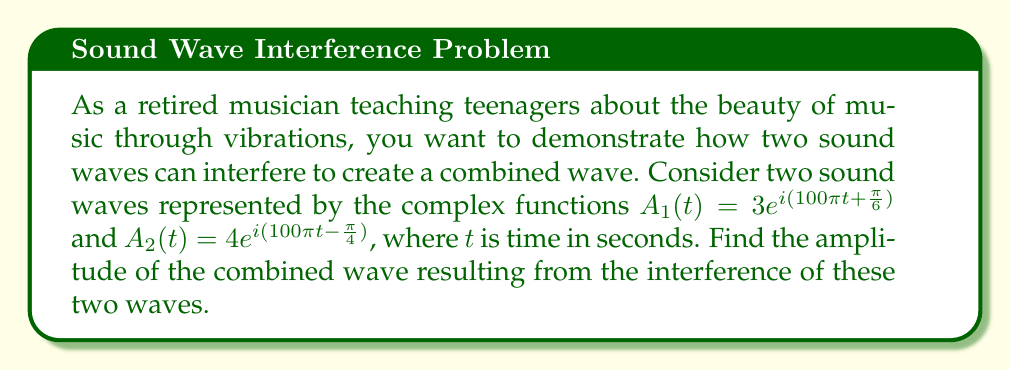What is the answer to this math problem? To find the amplitude of the combined wave, we need to follow these steps:

1) The combined wave is the sum of the two individual waves:
   $$A_{total}(t) = A_1(t) + A_2(t) = 3e^{i(100\pi t + \frac{\pi}{6})} + 4e^{i(100\pi t - \frac{\pi}{4})}$$

2) We can factor out the common $e^{i100\pi t}$ term:
   $$A_{total}(t) = e^{i100\pi t}(3e^{i\frac{\pi}{6}} + 4e^{-i\frac{\pi}{4}})$$

3) Let's focus on the term in parentheses. We need to add these complex numbers:
   $$3e^{i\frac{\pi}{6}} + 4e^{-i\frac{\pi}{4}}$$

4) Convert each complex number to rectangular form:
   $3e^{i\frac{\pi}{6}} = 3(\cos\frac{\pi}{6} + i\sin\frac{\pi}{6}) = 3(\frac{\sqrt{3}}{2} + i\frac{1}{2}) = \frac{3\sqrt{3}}{2} + i\frac{3}{2}$
   $4e^{-i\frac{\pi}{4}} = 4(\cos\frac{\pi}{4} - i\sin\frac{\pi}{4}) = 4(\frac{\sqrt{2}}{2} - i\frac{\sqrt{2}}{2}) = 2\sqrt{2} - i2\sqrt{2}$

5) Add these complex numbers:
   $$(\frac{3\sqrt{3}}{2} + i\frac{3}{2}) + (2\sqrt{2} - i2\sqrt{2}) = (\frac{3\sqrt{3}}{2} + 2\sqrt{2}) + i(\frac{3}{2} - 2\sqrt{2})$$

6) The amplitude of the combined wave is the magnitude of this complex number:
   $$\sqrt{(\frac{3\sqrt{3}}{2} + 2\sqrt{2})^2 + (\frac{3}{2} - 2\sqrt{2})^2}$$

7) Simplify:
   $$\sqrt{(\frac{9}{4} + 3\sqrt{6} + 8) + (\frac{9}{4} - 3\sqrt{2} + 8)} = \sqrt{\frac{41}{2} + 3\sqrt{6} - 3\sqrt{2}}$$

This is the amplitude of the combined wave.
Answer: The amplitude of the combined wave is $\sqrt{\frac{41}{2} + 3\sqrt{6} - 3\sqrt{2}}$. 